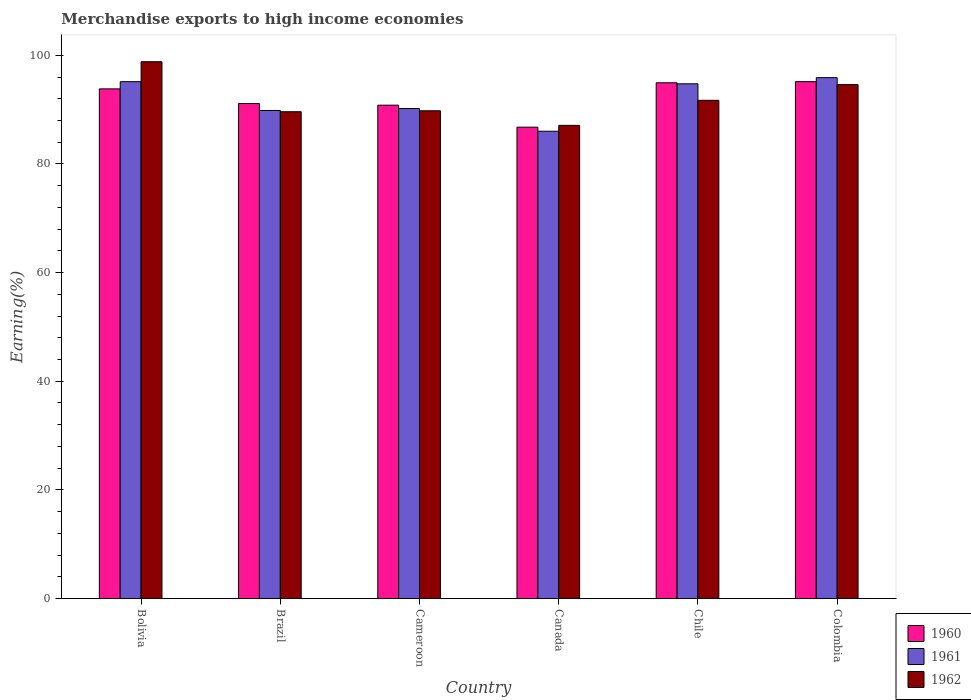How many different coloured bars are there?
Make the answer very short. 3. Are the number of bars on each tick of the X-axis equal?
Ensure brevity in your answer.  Yes. How many bars are there on the 4th tick from the right?
Provide a short and direct response. 3. What is the label of the 5th group of bars from the left?
Provide a succinct answer. Chile. In how many cases, is the number of bars for a given country not equal to the number of legend labels?
Your answer should be compact. 0. What is the percentage of amount earned from merchandise exports in 1961 in Canada?
Give a very brief answer. 86.02. Across all countries, what is the maximum percentage of amount earned from merchandise exports in 1961?
Provide a short and direct response. 95.89. Across all countries, what is the minimum percentage of amount earned from merchandise exports in 1961?
Ensure brevity in your answer.  86.02. What is the total percentage of amount earned from merchandise exports in 1960 in the graph?
Offer a very short reply. 552.59. What is the difference between the percentage of amount earned from merchandise exports in 1961 in Chile and that in Colombia?
Your answer should be compact. -1.14. What is the difference between the percentage of amount earned from merchandise exports in 1962 in Bolivia and the percentage of amount earned from merchandise exports in 1961 in Cameroon?
Provide a succinct answer. 8.62. What is the average percentage of amount earned from merchandise exports in 1960 per country?
Offer a terse response. 92.1. What is the difference between the percentage of amount earned from merchandise exports of/in 1961 and percentage of amount earned from merchandise exports of/in 1962 in Canada?
Keep it short and to the point. -1.08. What is the ratio of the percentage of amount earned from merchandise exports in 1962 in Cameroon to that in Chile?
Your answer should be compact. 0.98. Is the percentage of amount earned from merchandise exports in 1961 in Cameroon less than that in Canada?
Offer a very short reply. No. Is the difference between the percentage of amount earned from merchandise exports in 1961 in Brazil and Colombia greater than the difference between the percentage of amount earned from merchandise exports in 1962 in Brazil and Colombia?
Offer a terse response. No. What is the difference between the highest and the second highest percentage of amount earned from merchandise exports in 1961?
Provide a short and direct response. -0.39. What is the difference between the highest and the lowest percentage of amount earned from merchandise exports in 1960?
Your response must be concise. 8.38. In how many countries, is the percentage of amount earned from merchandise exports in 1962 greater than the average percentage of amount earned from merchandise exports in 1962 taken over all countries?
Your answer should be compact. 2. Is the sum of the percentage of amount earned from merchandise exports in 1960 in Cameroon and Colombia greater than the maximum percentage of amount earned from merchandise exports in 1962 across all countries?
Make the answer very short. Yes. What does the 3rd bar from the right in Brazil represents?
Make the answer very short. 1960. Is it the case that in every country, the sum of the percentage of amount earned from merchandise exports in 1962 and percentage of amount earned from merchandise exports in 1961 is greater than the percentage of amount earned from merchandise exports in 1960?
Offer a terse response. Yes. Are all the bars in the graph horizontal?
Give a very brief answer. No. How many countries are there in the graph?
Give a very brief answer. 6. Where does the legend appear in the graph?
Your answer should be very brief. Bottom right. How many legend labels are there?
Give a very brief answer. 3. How are the legend labels stacked?
Ensure brevity in your answer.  Vertical. What is the title of the graph?
Give a very brief answer. Merchandise exports to high income economies. Does "1965" appear as one of the legend labels in the graph?
Keep it short and to the point. No. What is the label or title of the X-axis?
Make the answer very short. Country. What is the label or title of the Y-axis?
Your answer should be compact. Earning(%). What is the Earning(%) of 1960 in Bolivia?
Make the answer very short. 93.81. What is the Earning(%) in 1961 in Bolivia?
Offer a terse response. 95.14. What is the Earning(%) of 1962 in Bolivia?
Offer a terse response. 98.82. What is the Earning(%) in 1960 in Brazil?
Provide a succinct answer. 91.12. What is the Earning(%) of 1961 in Brazil?
Provide a short and direct response. 89.84. What is the Earning(%) in 1962 in Brazil?
Your answer should be compact. 89.61. What is the Earning(%) of 1960 in Cameroon?
Your response must be concise. 90.82. What is the Earning(%) of 1961 in Cameroon?
Keep it short and to the point. 90.19. What is the Earning(%) in 1962 in Cameroon?
Keep it short and to the point. 89.78. What is the Earning(%) of 1960 in Canada?
Make the answer very short. 86.77. What is the Earning(%) of 1961 in Canada?
Ensure brevity in your answer.  86.02. What is the Earning(%) in 1962 in Canada?
Your answer should be compact. 87.1. What is the Earning(%) in 1960 in Chile?
Your answer should be compact. 94.94. What is the Earning(%) of 1961 in Chile?
Your response must be concise. 94.75. What is the Earning(%) of 1962 in Chile?
Your answer should be very brief. 91.71. What is the Earning(%) in 1960 in Colombia?
Give a very brief answer. 95.14. What is the Earning(%) in 1961 in Colombia?
Offer a very short reply. 95.89. What is the Earning(%) in 1962 in Colombia?
Offer a terse response. 94.6. Across all countries, what is the maximum Earning(%) of 1960?
Provide a short and direct response. 95.14. Across all countries, what is the maximum Earning(%) in 1961?
Make the answer very short. 95.89. Across all countries, what is the maximum Earning(%) of 1962?
Your answer should be very brief. 98.82. Across all countries, what is the minimum Earning(%) of 1960?
Ensure brevity in your answer.  86.77. Across all countries, what is the minimum Earning(%) of 1961?
Your answer should be compact. 86.02. Across all countries, what is the minimum Earning(%) of 1962?
Keep it short and to the point. 87.1. What is the total Earning(%) in 1960 in the graph?
Provide a succinct answer. 552.59. What is the total Earning(%) of 1961 in the graph?
Make the answer very short. 551.83. What is the total Earning(%) of 1962 in the graph?
Your response must be concise. 551.61. What is the difference between the Earning(%) in 1960 in Bolivia and that in Brazil?
Make the answer very short. 2.7. What is the difference between the Earning(%) of 1961 in Bolivia and that in Brazil?
Give a very brief answer. 5.3. What is the difference between the Earning(%) of 1962 in Bolivia and that in Brazil?
Your response must be concise. 9.21. What is the difference between the Earning(%) in 1960 in Bolivia and that in Cameroon?
Provide a succinct answer. 3. What is the difference between the Earning(%) of 1961 in Bolivia and that in Cameroon?
Your answer should be compact. 4.95. What is the difference between the Earning(%) of 1962 in Bolivia and that in Cameroon?
Ensure brevity in your answer.  9.03. What is the difference between the Earning(%) in 1960 in Bolivia and that in Canada?
Provide a succinct answer. 7.05. What is the difference between the Earning(%) of 1961 in Bolivia and that in Canada?
Make the answer very short. 9.13. What is the difference between the Earning(%) in 1962 in Bolivia and that in Canada?
Provide a succinct answer. 11.71. What is the difference between the Earning(%) in 1960 in Bolivia and that in Chile?
Keep it short and to the point. -1.12. What is the difference between the Earning(%) in 1961 in Bolivia and that in Chile?
Make the answer very short. 0.39. What is the difference between the Earning(%) in 1962 in Bolivia and that in Chile?
Provide a succinct answer. 7.11. What is the difference between the Earning(%) of 1960 in Bolivia and that in Colombia?
Offer a terse response. -1.33. What is the difference between the Earning(%) in 1961 in Bolivia and that in Colombia?
Provide a succinct answer. -0.74. What is the difference between the Earning(%) in 1962 in Bolivia and that in Colombia?
Give a very brief answer. 4.22. What is the difference between the Earning(%) in 1960 in Brazil and that in Cameroon?
Your answer should be compact. 0.3. What is the difference between the Earning(%) of 1961 in Brazil and that in Cameroon?
Ensure brevity in your answer.  -0.35. What is the difference between the Earning(%) of 1962 in Brazil and that in Cameroon?
Offer a terse response. -0.17. What is the difference between the Earning(%) of 1960 in Brazil and that in Canada?
Offer a very short reply. 4.35. What is the difference between the Earning(%) of 1961 in Brazil and that in Canada?
Your answer should be compact. 3.82. What is the difference between the Earning(%) in 1962 in Brazil and that in Canada?
Provide a succinct answer. 2.51. What is the difference between the Earning(%) in 1960 in Brazil and that in Chile?
Your response must be concise. -3.82. What is the difference between the Earning(%) in 1961 in Brazil and that in Chile?
Your answer should be very brief. -4.91. What is the difference between the Earning(%) of 1962 in Brazil and that in Chile?
Your answer should be compact. -2.1. What is the difference between the Earning(%) of 1960 in Brazil and that in Colombia?
Ensure brevity in your answer.  -4.03. What is the difference between the Earning(%) of 1961 in Brazil and that in Colombia?
Ensure brevity in your answer.  -6.05. What is the difference between the Earning(%) in 1962 in Brazil and that in Colombia?
Provide a short and direct response. -4.99. What is the difference between the Earning(%) of 1960 in Cameroon and that in Canada?
Your answer should be very brief. 4.05. What is the difference between the Earning(%) in 1961 in Cameroon and that in Canada?
Offer a very short reply. 4.18. What is the difference between the Earning(%) of 1962 in Cameroon and that in Canada?
Your response must be concise. 2.68. What is the difference between the Earning(%) of 1960 in Cameroon and that in Chile?
Provide a short and direct response. -4.12. What is the difference between the Earning(%) in 1961 in Cameroon and that in Chile?
Your answer should be very brief. -4.56. What is the difference between the Earning(%) of 1962 in Cameroon and that in Chile?
Offer a terse response. -1.93. What is the difference between the Earning(%) in 1960 in Cameroon and that in Colombia?
Make the answer very short. -4.33. What is the difference between the Earning(%) in 1961 in Cameroon and that in Colombia?
Make the answer very short. -5.69. What is the difference between the Earning(%) in 1962 in Cameroon and that in Colombia?
Keep it short and to the point. -4.81. What is the difference between the Earning(%) of 1960 in Canada and that in Chile?
Give a very brief answer. -8.17. What is the difference between the Earning(%) of 1961 in Canada and that in Chile?
Provide a short and direct response. -8.73. What is the difference between the Earning(%) in 1962 in Canada and that in Chile?
Provide a succinct answer. -4.61. What is the difference between the Earning(%) of 1960 in Canada and that in Colombia?
Keep it short and to the point. -8.38. What is the difference between the Earning(%) in 1961 in Canada and that in Colombia?
Ensure brevity in your answer.  -9.87. What is the difference between the Earning(%) in 1962 in Canada and that in Colombia?
Your response must be concise. -7.5. What is the difference between the Earning(%) in 1960 in Chile and that in Colombia?
Your answer should be very brief. -0.21. What is the difference between the Earning(%) in 1961 in Chile and that in Colombia?
Give a very brief answer. -1.14. What is the difference between the Earning(%) in 1962 in Chile and that in Colombia?
Your answer should be compact. -2.89. What is the difference between the Earning(%) in 1960 in Bolivia and the Earning(%) in 1961 in Brazil?
Your response must be concise. 3.97. What is the difference between the Earning(%) in 1960 in Bolivia and the Earning(%) in 1962 in Brazil?
Your response must be concise. 4.21. What is the difference between the Earning(%) in 1961 in Bolivia and the Earning(%) in 1962 in Brazil?
Your answer should be very brief. 5.54. What is the difference between the Earning(%) in 1960 in Bolivia and the Earning(%) in 1961 in Cameroon?
Your answer should be compact. 3.62. What is the difference between the Earning(%) in 1960 in Bolivia and the Earning(%) in 1962 in Cameroon?
Keep it short and to the point. 4.03. What is the difference between the Earning(%) in 1961 in Bolivia and the Earning(%) in 1962 in Cameroon?
Provide a succinct answer. 5.36. What is the difference between the Earning(%) in 1960 in Bolivia and the Earning(%) in 1961 in Canada?
Keep it short and to the point. 7.8. What is the difference between the Earning(%) of 1960 in Bolivia and the Earning(%) of 1962 in Canada?
Ensure brevity in your answer.  6.71. What is the difference between the Earning(%) of 1961 in Bolivia and the Earning(%) of 1962 in Canada?
Provide a short and direct response. 8.04. What is the difference between the Earning(%) in 1960 in Bolivia and the Earning(%) in 1961 in Chile?
Your answer should be compact. -0.94. What is the difference between the Earning(%) of 1960 in Bolivia and the Earning(%) of 1962 in Chile?
Provide a succinct answer. 2.11. What is the difference between the Earning(%) of 1961 in Bolivia and the Earning(%) of 1962 in Chile?
Offer a terse response. 3.44. What is the difference between the Earning(%) in 1960 in Bolivia and the Earning(%) in 1961 in Colombia?
Ensure brevity in your answer.  -2.07. What is the difference between the Earning(%) of 1960 in Bolivia and the Earning(%) of 1962 in Colombia?
Keep it short and to the point. -0.78. What is the difference between the Earning(%) in 1961 in Bolivia and the Earning(%) in 1962 in Colombia?
Offer a very short reply. 0.55. What is the difference between the Earning(%) of 1960 in Brazil and the Earning(%) of 1961 in Cameroon?
Provide a succinct answer. 0.92. What is the difference between the Earning(%) of 1960 in Brazil and the Earning(%) of 1962 in Cameroon?
Offer a terse response. 1.34. What is the difference between the Earning(%) in 1961 in Brazil and the Earning(%) in 1962 in Cameroon?
Your answer should be compact. 0.06. What is the difference between the Earning(%) in 1960 in Brazil and the Earning(%) in 1961 in Canada?
Ensure brevity in your answer.  5.1. What is the difference between the Earning(%) in 1960 in Brazil and the Earning(%) in 1962 in Canada?
Ensure brevity in your answer.  4.02. What is the difference between the Earning(%) in 1961 in Brazil and the Earning(%) in 1962 in Canada?
Your answer should be very brief. 2.74. What is the difference between the Earning(%) in 1960 in Brazil and the Earning(%) in 1961 in Chile?
Offer a terse response. -3.63. What is the difference between the Earning(%) in 1960 in Brazil and the Earning(%) in 1962 in Chile?
Your response must be concise. -0.59. What is the difference between the Earning(%) of 1961 in Brazil and the Earning(%) of 1962 in Chile?
Provide a succinct answer. -1.87. What is the difference between the Earning(%) in 1960 in Brazil and the Earning(%) in 1961 in Colombia?
Provide a short and direct response. -4.77. What is the difference between the Earning(%) of 1960 in Brazil and the Earning(%) of 1962 in Colombia?
Ensure brevity in your answer.  -3.48. What is the difference between the Earning(%) in 1961 in Brazil and the Earning(%) in 1962 in Colombia?
Offer a very short reply. -4.76. What is the difference between the Earning(%) in 1960 in Cameroon and the Earning(%) in 1961 in Canada?
Make the answer very short. 4.8. What is the difference between the Earning(%) of 1960 in Cameroon and the Earning(%) of 1962 in Canada?
Keep it short and to the point. 3.71. What is the difference between the Earning(%) in 1961 in Cameroon and the Earning(%) in 1962 in Canada?
Your response must be concise. 3.09. What is the difference between the Earning(%) of 1960 in Cameroon and the Earning(%) of 1961 in Chile?
Keep it short and to the point. -3.94. What is the difference between the Earning(%) in 1960 in Cameroon and the Earning(%) in 1962 in Chile?
Your response must be concise. -0.89. What is the difference between the Earning(%) in 1961 in Cameroon and the Earning(%) in 1962 in Chile?
Keep it short and to the point. -1.51. What is the difference between the Earning(%) in 1960 in Cameroon and the Earning(%) in 1961 in Colombia?
Your answer should be compact. -5.07. What is the difference between the Earning(%) in 1960 in Cameroon and the Earning(%) in 1962 in Colombia?
Offer a very short reply. -3.78. What is the difference between the Earning(%) of 1961 in Cameroon and the Earning(%) of 1962 in Colombia?
Ensure brevity in your answer.  -4.4. What is the difference between the Earning(%) of 1960 in Canada and the Earning(%) of 1961 in Chile?
Provide a succinct answer. -7.98. What is the difference between the Earning(%) in 1960 in Canada and the Earning(%) in 1962 in Chile?
Give a very brief answer. -4.94. What is the difference between the Earning(%) in 1961 in Canada and the Earning(%) in 1962 in Chile?
Provide a short and direct response. -5.69. What is the difference between the Earning(%) of 1960 in Canada and the Earning(%) of 1961 in Colombia?
Your answer should be compact. -9.12. What is the difference between the Earning(%) in 1960 in Canada and the Earning(%) in 1962 in Colombia?
Your answer should be compact. -7.83. What is the difference between the Earning(%) of 1961 in Canada and the Earning(%) of 1962 in Colombia?
Keep it short and to the point. -8.58. What is the difference between the Earning(%) of 1960 in Chile and the Earning(%) of 1961 in Colombia?
Your response must be concise. -0.95. What is the difference between the Earning(%) in 1960 in Chile and the Earning(%) in 1962 in Colombia?
Offer a very short reply. 0.34. What is the difference between the Earning(%) in 1961 in Chile and the Earning(%) in 1962 in Colombia?
Provide a succinct answer. 0.15. What is the average Earning(%) in 1960 per country?
Your response must be concise. 92.1. What is the average Earning(%) of 1961 per country?
Make the answer very short. 91.97. What is the average Earning(%) of 1962 per country?
Provide a succinct answer. 91.94. What is the difference between the Earning(%) of 1960 and Earning(%) of 1961 in Bolivia?
Your response must be concise. -1.33. What is the difference between the Earning(%) of 1960 and Earning(%) of 1962 in Bolivia?
Provide a succinct answer. -5. What is the difference between the Earning(%) in 1961 and Earning(%) in 1962 in Bolivia?
Offer a very short reply. -3.67. What is the difference between the Earning(%) in 1960 and Earning(%) in 1961 in Brazil?
Give a very brief answer. 1.28. What is the difference between the Earning(%) in 1960 and Earning(%) in 1962 in Brazil?
Your response must be concise. 1.51. What is the difference between the Earning(%) of 1961 and Earning(%) of 1962 in Brazil?
Offer a terse response. 0.23. What is the difference between the Earning(%) in 1960 and Earning(%) in 1961 in Cameroon?
Give a very brief answer. 0.62. What is the difference between the Earning(%) in 1960 and Earning(%) in 1962 in Cameroon?
Provide a short and direct response. 1.03. What is the difference between the Earning(%) in 1961 and Earning(%) in 1962 in Cameroon?
Offer a very short reply. 0.41. What is the difference between the Earning(%) of 1960 and Earning(%) of 1961 in Canada?
Provide a succinct answer. 0.75. What is the difference between the Earning(%) in 1960 and Earning(%) in 1962 in Canada?
Give a very brief answer. -0.33. What is the difference between the Earning(%) in 1961 and Earning(%) in 1962 in Canada?
Ensure brevity in your answer.  -1.08. What is the difference between the Earning(%) of 1960 and Earning(%) of 1961 in Chile?
Ensure brevity in your answer.  0.19. What is the difference between the Earning(%) of 1960 and Earning(%) of 1962 in Chile?
Your response must be concise. 3.23. What is the difference between the Earning(%) in 1961 and Earning(%) in 1962 in Chile?
Keep it short and to the point. 3.04. What is the difference between the Earning(%) of 1960 and Earning(%) of 1961 in Colombia?
Keep it short and to the point. -0.74. What is the difference between the Earning(%) in 1960 and Earning(%) in 1962 in Colombia?
Provide a succinct answer. 0.55. What is the difference between the Earning(%) of 1961 and Earning(%) of 1962 in Colombia?
Make the answer very short. 1.29. What is the ratio of the Earning(%) in 1960 in Bolivia to that in Brazil?
Provide a succinct answer. 1.03. What is the ratio of the Earning(%) in 1961 in Bolivia to that in Brazil?
Your answer should be very brief. 1.06. What is the ratio of the Earning(%) in 1962 in Bolivia to that in Brazil?
Your answer should be very brief. 1.1. What is the ratio of the Earning(%) of 1960 in Bolivia to that in Cameroon?
Ensure brevity in your answer.  1.03. What is the ratio of the Earning(%) of 1961 in Bolivia to that in Cameroon?
Provide a succinct answer. 1.05. What is the ratio of the Earning(%) of 1962 in Bolivia to that in Cameroon?
Your answer should be compact. 1.1. What is the ratio of the Earning(%) of 1960 in Bolivia to that in Canada?
Offer a terse response. 1.08. What is the ratio of the Earning(%) in 1961 in Bolivia to that in Canada?
Offer a terse response. 1.11. What is the ratio of the Earning(%) in 1962 in Bolivia to that in Canada?
Your answer should be compact. 1.13. What is the ratio of the Earning(%) in 1960 in Bolivia to that in Chile?
Offer a terse response. 0.99. What is the ratio of the Earning(%) of 1961 in Bolivia to that in Chile?
Give a very brief answer. 1. What is the ratio of the Earning(%) of 1962 in Bolivia to that in Chile?
Your response must be concise. 1.08. What is the ratio of the Earning(%) in 1960 in Bolivia to that in Colombia?
Provide a short and direct response. 0.99. What is the ratio of the Earning(%) in 1962 in Bolivia to that in Colombia?
Ensure brevity in your answer.  1.04. What is the ratio of the Earning(%) in 1962 in Brazil to that in Cameroon?
Give a very brief answer. 1. What is the ratio of the Earning(%) in 1960 in Brazil to that in Canada?
Provide a succinct answer. 1.05. What is the ratio of the Earning(%) of 1961 in Brazil to that in Canada?
Offer a very short reply. 1.04. What is the ratio of the Earning(%) in 1962 in Brazil to that in Canada?
Ensure brevity in your answer.  1.03. What is the ratio of the Earning(%) in 1960 in Brazil to that in Chile?
Offer a terse response. 0.96. What is the ratio of the Earning(%) in 1961 in Brazil to that in Chile?
Keep it short and to the point. 0.95. What is the ratio of the Earning(%) in 1962 in Brazil to that in Chile?
Offer a very short reply. 0.98. What is the ratio of the Earning(%) in 1960 in Brazil to that in Colombia?
Offer a terse response. 0.96. What is the ratio of the Earning(%) of 1961 in Brazil to that in Colombia?
Your answer should be very brief. 0.94. What is the ratio of the Earning(%) of 1962 in Brazil to that in Colombia?
Offer a terse response. 0.95. What is the ratio of the Earning(%) of 1960 in Cameroon to that in Canada?
Your answer should be very brief. 1.05. What is the ratio of the Earning(%) of 1961 in Cameroon to that in Canada?
Ensure brevity in your answer.  1.05. What is the ratio of the Earning(%) in 1962 in Cameroon to that in Canada?
Provide a succinct answer. 1.03. What is the ratio of the Earning(%) of 1960 in Cameroon to that in Chile?
Offer a very short reply. 0.96. What is the ratio of the Earning(%) in 1961 in Cameroon to that in Chile?
Offer a terse response. 0.95. What is the ratio of the Earning(%) of 1960 in Cameroon to that in Colombia?
Provide a short and direct response. 0.95. What is the ratio of the Earning(%) of 1961 in Cameroon to that in Colombia?
Make the answer very short. 0.94. What is the ratio of the Earning(%) in 1962 in Cameroon to that in Colombia?
Give a very brief answer. 0.95. What is the ratio of the Earning(%) in 1960 in Canada to that in Chile?
Ensure brevity in your answer.  0.91. What is the ratio of the Earning(%) of 1961 in Canada to that in Chile?
Provide a short and direct response. 0.91. What is the ratio of the Earning(%) of 1962 in Canada to that in Chile?
Provide a short and direct response. 0.95. What is the ratio of the Earning(%) of 1960 in Canada to that in Colombia?
Give a very brief answer. 0.91. What is the ratio of the Earning(%) in 1961 in Canada to that in Colombia?
Your answer should be very brief. 0.9. What is the ratio of the Earning(%) in 1962 in Canada to that in Colombia?
Your response must be concise. 0.92. What is the ratio of the Earning(%) of 1962 in Chile to that in Colombia?
Your answer should be very brief. 0.97. What is the difference between the highest and the second highest Earning(%) in 1960?
Provide a short and direct response. 0.21. What is the difference between the highest and the second highest Earning(%) in 1961?
Give a very brief answer. 0.74. What is the difference between the highest and the second highest Earning(%) in 1962?
Make the answer very short. 4.22. What is the difference between the highest and the lowest Earning(%) of 1960?
Ensure brevity in your answer.  8.38. What is the difference between the highest and the lowest Earning(%) of 1961?
Keep it short and to the point. 9.87. What is the difference between the highest and the lowest Earning(%) in 1962?
Your answer should be compact. 11.71. 